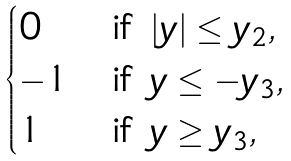Convert formula to latex. <formula><loc_0><loc_0><loc_500><loc_500>\begin{cases} 0 & \text {if } | y | \leq y _ { 2 } , \\ - 1 & \text {if } y \leq - y _ { 3 } , \\ 1 & \text {if } y \geq y _ { 3 } , \end{cases}</formula> 